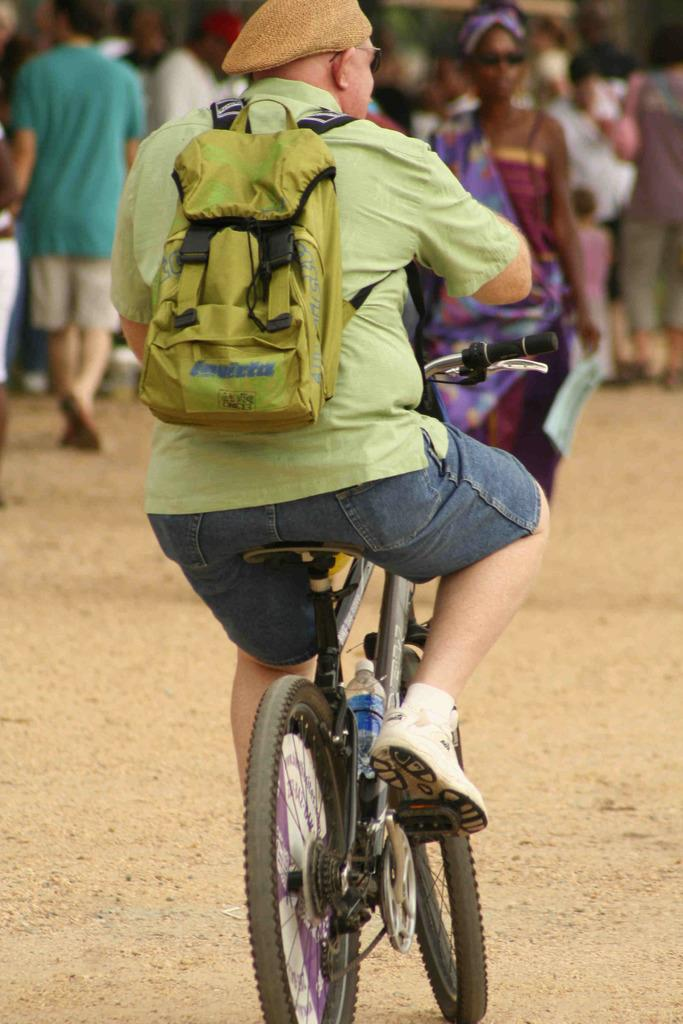What is the main activity of the person in the image? The person is sitting and riding a bicycle. What is the person wearing on their back? The person is wearing a bag. What type of headwear is the person wearing? The person is wearing a cap. Can you describe the people in front of the cyclist? There are other persons in front of the cyclist. What type of sheet is being used by the person to ride the bicycle? There is no sheet present in the image; the person is riding the bicycle without any additional materials. 